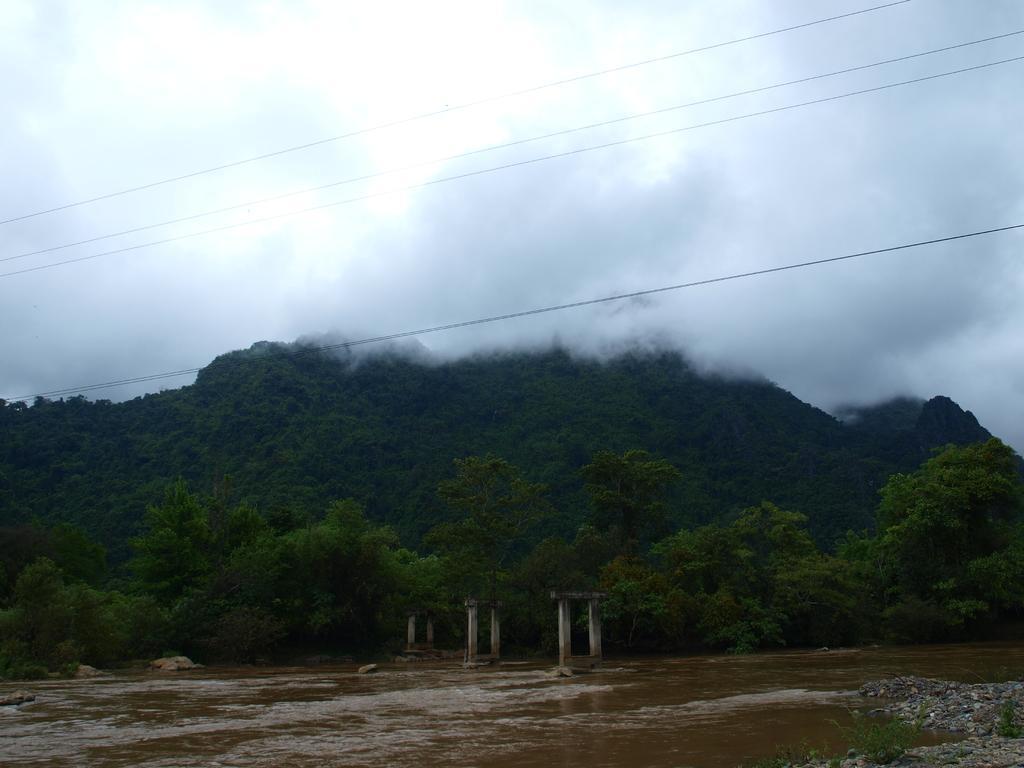How would you summarize this image in a sentence or two? In this image we can see the hills, trees and also the concrete structures. We can also see the water, plants and also stones. At the top we can see the clouds, fog and also wires. 